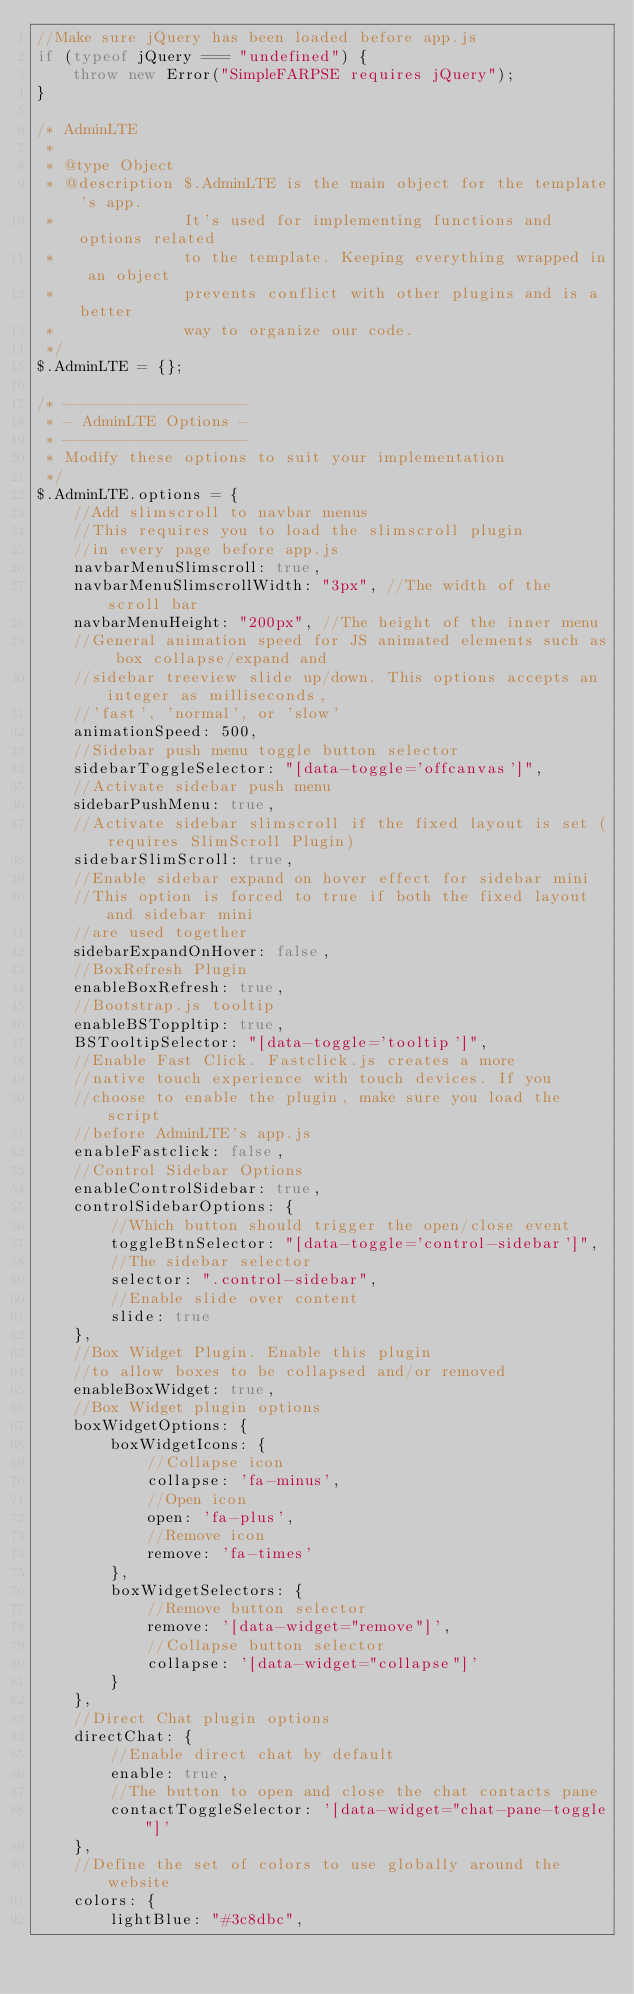<code> <loc_0><loc_0><loc_500><loc_500><_JavaScript_>//Make sure jQuery has been loaded before app.js
if (typeof jQuery === "undefined") {
    throw new Error("SimpleFARPSE requires jQuery");
}

/* AdminLTE
 *
 * @type Object
 * @description $.AdminLTE is the main object for the template's app.
 *              It's used for implementing functions and options related
 *              to the template. Keeping everything wrapped in an object
 *              prevents conflict with other plugins and is a better
 *              way to organize our code.
 */
$.AdminLTE = {};

/* --------------------
 * - AdminLTE Options -
 * --------------------
 * Modify these options to suit your implementation
 */
$.AdminLTE.options = {
    //Add slimscroll to navbar menus
    //This requires you to load the slimscroll plugin
    //in every page before app.js
    navbarMenuSlimscroll: true,
    navbarMenuSlimscrollWidth: "3px", //The width of the scroll bar
    navbarMenuHeight: "200px", //The height of the inner menu
    //General animation speed for JS animated elements such as box collapse/expand and
    //sidebar treeview slide up/down. This options accepts an integer as milliseconds,
    //'fast', 'normal', or 'slow'
    animationSpeed: 500,
    //Sidebar push menu toggle button selector
    sidebarToggleSelector: "[data-toggle='offcanvas']",
    //Activate sidebar push menu
    sidebarPushMenu: true,
    //Activate sidebar slimscroll if the fixed layout is set (requires SlimScroll Plugin)
    sidebarSlimScroll: true,
    //Enable sidebar expand on hover effect for sidebar mini
    //This option is forced to true if both the fixed layout and sidebar mini
    //are used together
    sidebarExpandOnHover: false,
    //BoxRefresh Plugin
    enableBoxRefresh: true,
    //Bootstrap.js tooltip
    enableBSToppltip: true,
    BSTooltipSelector: "[data-toggle='tooltip']",
    //Enable Fast Click. Fastclick.js creates a more
    //native touch experience with touch devices. If you
    //choose to enable the plugin, make sure you load the script
    //before AdminLTE's app.js
    enableFastclick: false,
    //Control Sidebar Options
    enableControlSidebar: true,
    controlSidebarOptions: {
        //Which button should trigger the open/close event
        toggleBtnSelector: "[data-toggle='control-sidebar']",
        //The sidebar selector
        selector: ".control-sidebar",
        //Enable slide over content
        slide: true
    },
    //Box Widget Plugin. Enable this plugin
    //to allow boxes to be collapsed and/or removed
    enableBoxWidget: true,
    //Box Widget plugin options
    boxWidgetOptions: {
        boxWidgetIcons: {
            //Collapse icon
            collapse: 'fa-minus',
            //Open icon
            open: 'fa-plus',
            //Remove icon
            remove: 'fa-times'
        },
        boxWidgetSelectors: {
            //Remove button selector
            remove: '[data-widget="remove"]',
            //Collapse button selector
            collapse: '[data-widget="collapse"]'
        }
    },
    //Direct Chat plugin options
    directChat: {
        //Enable direct chat by default
        enable: true,
        //The button to open and close the chat contacts pane
        contactToggleSelector: '[data-widget="chat-pane-toggle"]'
    },
    //Define the set of colors to use globally around the website
    colors: {
        lightBlue: "#3c8dbc",</code> 